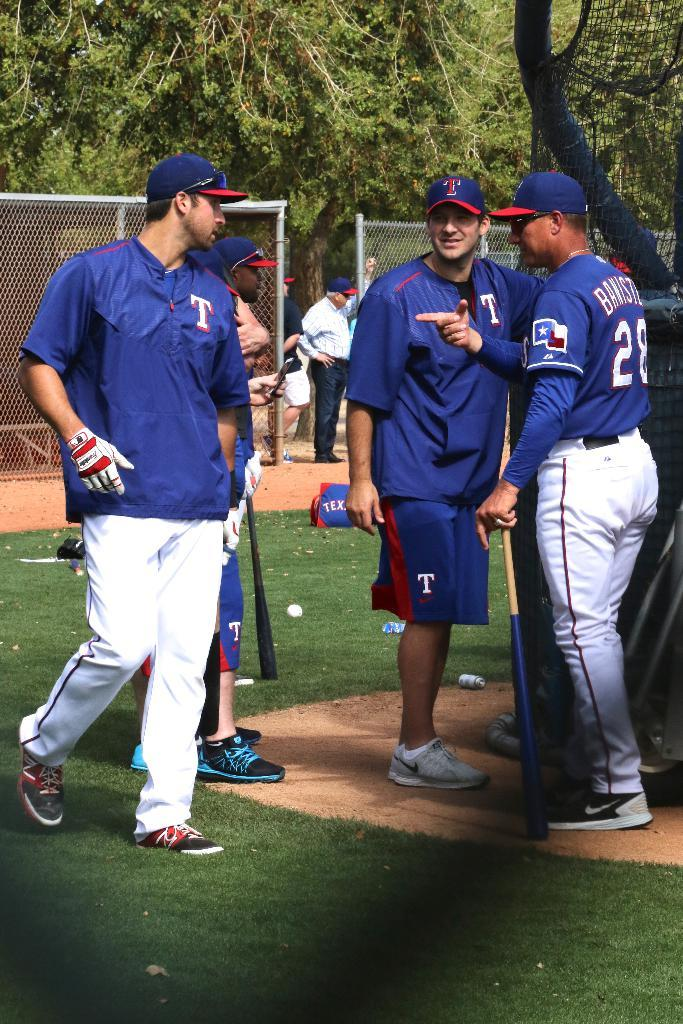<image>
Give a short and clear explanation of the subsequent image. Some sportsmen, one of whom as the number 28 on his shirt. 